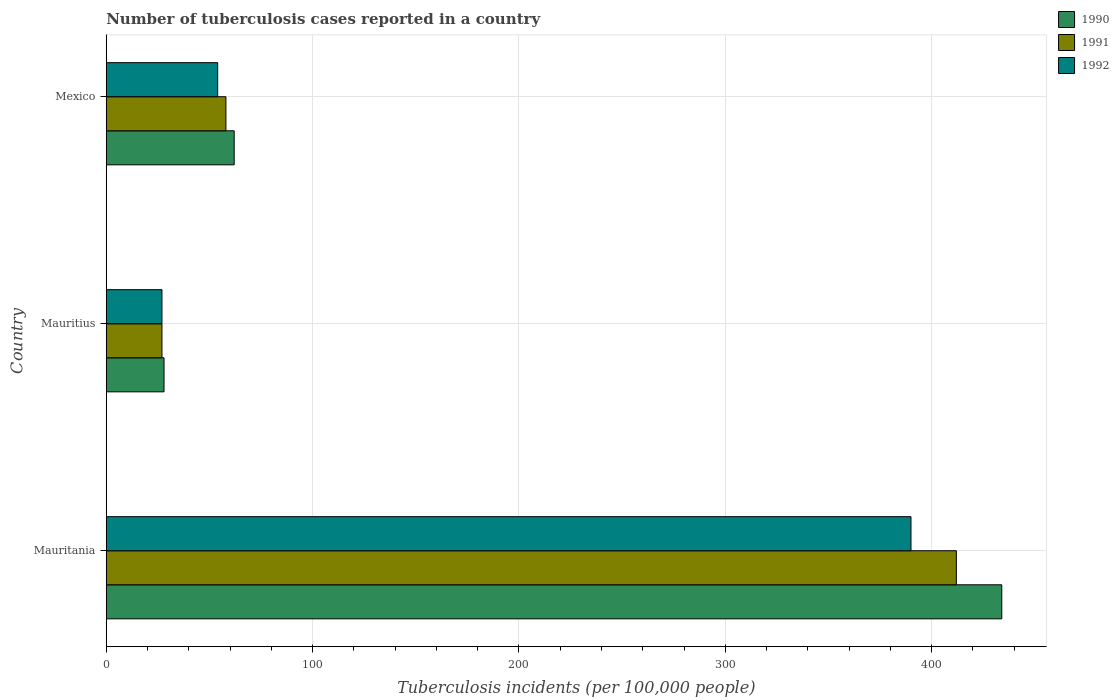How many different coloured bars are there?
Provide a succinct answer. 3. How many groups of bars are there?
Give a very brief answer. 3. How many bars are there on the 1st tick from the top?
Your answer should be very brief. 3. What is the label of the 2nd group of bars from the top?
Ensure brevity in your answer.  Mauritius. In how many cases, is the number of bars for a given country not equal to the number of legend labels?
Ensure brevity in your answer.  0. What is the number of tuberculosis cases reported in in 1990 in Mexico?
Give a very brief answer. 62. Across all countries, what is the maximum number of tuberculosis cases reported in in 1990?
Your response must be concise. 434. Across all countries, what is the minimum number of tuberculosis cases reported in in 1992?
Your answer should be very brief. 27. In which country was the number of tuberculosis cases reported in in 1992 maximum?
Your answer should be very brief. Mauritania. In which country was the number of tuberculosis cases reported in in 1990 minimum?
Your response must be concise. Mauritius. What is the total number of tuberculosis cases reported in in 1990 in the graph?
Offer a very short reply. 524. What is the difference between the number of tuberculosis cases reported in in 1991 in Mauritania and that in Mexico?
Offer a terse response. 354. What is the difference between the number of tuberculosis cases reported in in 1992 in Mauritius and the number of tuberculosis cases reported in in 1990 in Mauritania?
Your response must be concise. -407. What is the average number of tuberculosis cases reported in in 1991 per country?
Ensure brevity in your answer.  165.67. What is the difference between the number of tuberculosis cases reported in in 1992 and number of tuberculosis cases reported in in 1990 in Mauritius?
Ensure brevity in your answer.  -1. What is the ratio of the number of tuberculosis cases reported in in 1992 in Mauritius to that in Mexico?
Your answer should be compact. 0.5. Is the number of tuberculosis cases reported in in 1990 in Mauritania less than that in Mauritius?
Offer a terse response. No. What is the difference between the highest and the second highest number of tuberculosis cases reported in in 1990?
Make the answer very short. 372. What is the difference between the highest and the lowest number of tuberculosis cases reported in in 1990?
Give a very brief answer. 406. In how many countries, is the number of tuberculosis cases reported in in 1990 greater than the average number of tuberculosis cases reported in in 1990 taken over all countries?
Make the answer very short. 1. Is the sum of the number of tuberculosis cases reported in in 1990 in Mauritius and Mexico greater than the maximum number of tuberculosis cases reported in in 1992 across all countries?
Give a very brief answer. No. Is it the case that in every country, the sum of the number of tuberculosis cases reported in in 1990 and number of tuberculosis cases reported in in 1991 is greater than the number of tuberculosis cases reported in in 1992?
Make the answer very short. Yes. How many bars are there?
Keep it short and to the point. 9. Are all the bars in the graph horizontal?
Offer a very short reply. Yes. Are the values on the major ticks of X-axis written in scientific E-notation?
Your answer should be very brief. No. Does the graph contain any zero values?
Your answer should be compact. No. Where does the legend appear in the graph?
Give a very brief answer. Top right. What is the title of the graph?
Your answer should be very brief. Number of tuberculosis cases reported in a country. What is the label or title of the X-axis?
Keep it short and to the point. Tuberculosis incidents (per 100,0 people). What is the Tuberculosis incidents (per 100,000 people) of 1990 in Mauritania?
Ensure brevity in your answer.  434. What is the Tuberculosis incidents (per 100,000 people) of 1991 in Mauritania?
Your response must be concise. 412. What is the Tuberculosis incidents (per 100,000 people) of 1992 in Mauritania?
Make the answer very short. 390. What is the Tuberculosis incidents (per 100,000 people) of 1991 in Mauritius?
Your answer should be very brief. 27. What is the Tuberculosis incidents (per 100,000 people) of 1990 in Mexico?
Provide a short and direct response. 62. What is the Tuberculosis incidents (per 100,000 people) in 1992 in Mexico?
Give a very brief answer. 54. Across all countries, what is the maximum Tuberculosis incidents (per 100,000 people) of 1990?
Your answer should be compact. 434. Across all countries, what is the maximum Tuberculosis incidents (per 100,000 people) in 1991?
Keep it short and to the point. 412. Across all countries, what is the maximum Tuberculosis incidents (per 100,000 people) of 1992?
Ensure brevity in your answer.  390. Across all countries, what is the minimum Tuberculosis incidents (per 100,000 people) in 1990?
Your answer should be compact. 28. Across all countries, what is the minimum Tuberculosis incidents (per 100,000 people) in 1991?
Provide a succinct answer. 27. Across all countries, what is the minimum Tuberculosis incidents (per 100,000 people) of 1992?
Your answer should be very brief. 27. What is the total Tuberculosis incidents (per 100,000 people) of 1990 in the graph?
Your answer should be very brief. 524. What is the total Tuberculosis incidents (per 100,000 people) of 1991 in the graph?
Ensure brevity in your answer.  497. What is the total Tuberculosis incidents (per 100,000 people) in 1992 in the graph?
Offer a terse response. 471. What is the difference between the Tuberculosis incidents (per 100,000 people) in 1990 in Mauritania and that in Mauritius?
Ensure brevity in your answer.  406. What is the difference between the Tuberculosis incidents (per 100,000 people) of 1991 in Mauritania and that in Mauritius?
Your answer should be very brief. 385. What is the difference between the Tuberculosis incidents (per 100,000 people) of 1992 in Mauritania and that in Mauritius?
Provide a short and direct response. 363. What is the difference between the Tuberculosis incidents (per 100,000 people) in 1990 in Mauritania and that in Mexico?
Provide a succinct answer. 372. What is the difference between the Tuberculosis incidents (per 100,000 people) in 1991 in Mauritania and that in Mexico?
Give a very brief answer. 354. What is the difference between the Tuberculosis incidents (per 100,000 people) in 1992 in Mauritania and that in Mexico?
Provide a short and direct response. 336. What is the difference between the Tuberculosis incidents (per 100,000 people) of 1990 in Mauritius and that in Mexico?
Offer a terse response. -34. What is the difference between the Tuberculosis incidents (per 100,000 people) in 1991 in Mauritius and that in Mexico?
Keep it short and to the point. -31. What is the difference between the Tuberculosis incidents (per 100,000 people) in 1990 in Mauritania and the Tuberculosis incidents (per 100,000 people) in 1991 in Mauritius?
Offer a terse response. 407. What is the difference between the Tuberculosis incidents (per 100,000 people) of 1990 in Mauritania and the Tuberculosis incidents (per 100,000 people) of 1992 in Mauritius?
Offer a very short reply. 407. What is the difference between the Tuberculosis incidents (per 100,000 people) in 1991 in Mauritania and the Tuberculosis incidents (per 100,000 people) in 1992 in Mauritius?
Ensure brevity in your answer.  385. What is the difference between the Tuberculosis incidents (per 100,000 people) of 1990 in Mauritania and the Tuberculosis incidents (per 100,000 people) of 1991 in Mexico?
Provide a succinct answer. 376. What is the difference between the Tuberculosis incidents (per 100,000 people) in 1990 in Mauritania and the Tuberculosis incidents (per 100,000 people) in 1992 in Mexico?
Give a very brief answer. 380. What is the difference between the Tuberculosis incidents (per 100,000 people) of 1991 in Mauritania and the Tuberculosis incidents (per 100,000 people) of 1992 in Mexico?
Provide a short and direct response. 358. What is the difference between the Tuberculosis incidents (per 100,000 people) of 1990 in Mauritius and the Tuberculosis incidents (per 100,000 people) of 1991 in Mexico?
Your answer should be compact. -30. What is the difference between the Tuberculosis incidents (per 100,000 people) of 1991 in Mauritius and the Tuberculosis incidents (per 100,000 people) of 1992 in Mexico?
Give a very brief answer. -27. What is the average Tuberculosis incidents (per 100,000 people) in 1990 per country?
Your response must be concise. 174.67. What is the average Tuberculosis incidents (per 100,000 people) of 1991 per country?
Keep it short and to the point. 165.67. What is the average Tuberculosis incidents (per 100,000 people) of 1992 per country?
Ensure brevity in your answer.  157. What is the difference between the Tuberculosis incidents (per 100,000 people) of 1990 and Tuberculosis incidents (per 100,000 people) of 1991 in Mauritania?
Your response must be concise. 22. What is the difference between the Tuberculosis incidents (per 100,000 people) in 1991 and Tuberculosis incidents (per 100,000 people) in 1992 in Mauritania?
Ensure brevity in your answer.  22. What is the difference between the Tuberculosis incidents (per 100,000 people) of 1990 and Tuberculosis incidents (per 100,000 people) of 1991 in Mauritius?
Your answer should be very brief. 1. What is the difference between the Tuberculosis incidents (per 100,000 people) of 1990 and Tuberculosis incidents (per 100,000 people) of 1992 in Mexico?
Your answer should be very brief. 8. What is the difference between the Tuberculosis incidents (per 100,000 people) of 1991 and Tuberculosis incidents (per 100,000 people) of 1992 in Mexico?
Offer a terse response. 4. What is the ratio of the Tuberculosis incidents (per 100,000 people) of 1990 in Mauritania to that in Mauritius?
Provide a short and direct response. 15.5. What is the ratio of the Tuberculosis incidents (per 100,000 people) in 1991 in Mauritania to that in Mauritius?
Your answer should be very brief. 15.26. What is the ratio of the Tuberculosis incidents (per 100,000 people) in 1992 in Mauritania to that in Mauritius?
Provide a short and direct response. 14.44. What is the ratio of the Tuberculosis incidents (per 100,000 people) in 1991 in Mauritania to that in Mexico?
Keep it short and to the point. 7.1. What is the ratio of the Tuberculosis incidents (per 100,000 people) in 1992 in Mauritania to that in Mexico?
Provide a succinct answer. 7.22. What is the ratio of the Tuberculosis incidents (per 100,000 people) in 1990 in Mauritius to that in Mexico?
Ensure brevity in your answer.  0.45. What is the ratio of the Tuberculosis incidents (per 100,000 people) in 1991 in Mauritius to that in Mexico?
Provide a succinct answer. 0.47. What is the difference between the highest and the second highest Tuberculosis incidents (per 100,000 people) in 1990?
Provide a short and direct response. 372. What is the difference between the highest and the second highest Tuberculosis incidents (per 100,000 people) in 1991?
Your response must be concise. 354. What is the difference between the highest and the second highest Tuberculosis incidents (per 100,000 people) in 1992?
Make the answer very short. 336. What is the difference between the highest and the lowest Tuberculosis incidents (per 100,000 people) of 1990?
Offer a terse response. 406. What is the difference between the highest and the lowest Tuberculosis incidents (per 100,000 people) of 1991?
Keep it short and to the point. 385. What is the difference between the highest and the lowest Tuberculosis incidents (per 100,000 people) of 1992?
Provide a short and direct response. 363. 